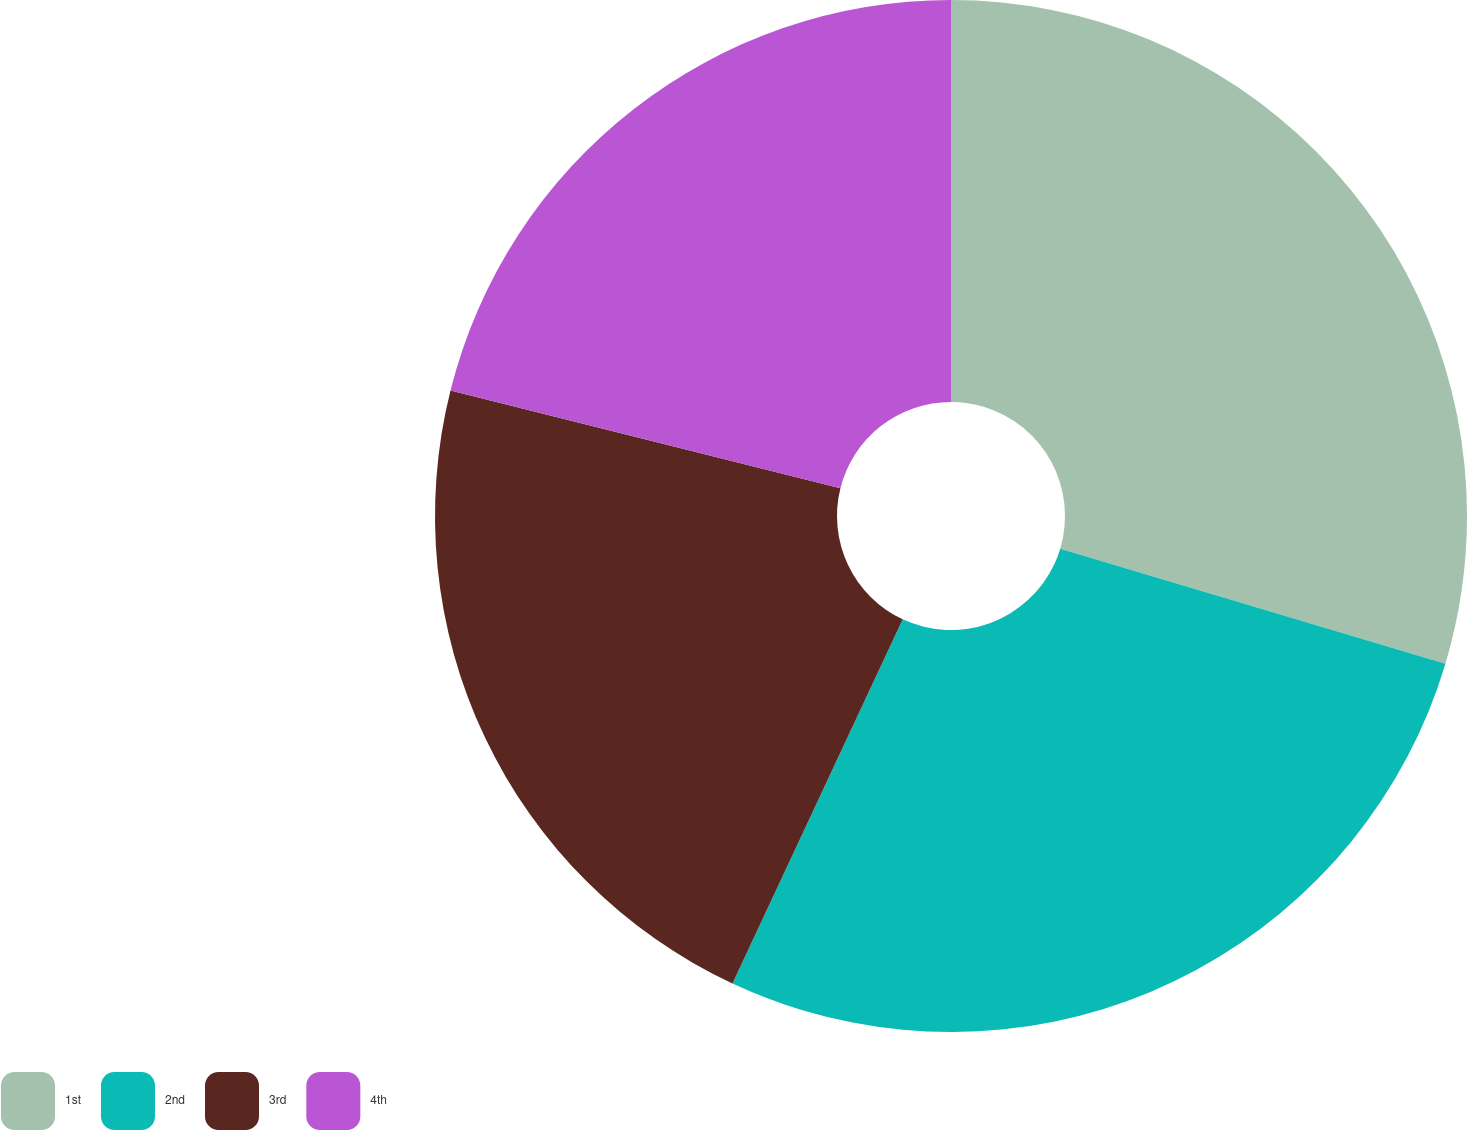Convert chart. <chart><loc_0><loc_0><loc_500><loc_500><pie_chart><fcel>1st<fcel>2nd<fcel>3rd<fcel>4th<nl><fcel>29.62%<fcel>27.34%<fcel>21.95%<fcel>21.09%<nl></chart> 